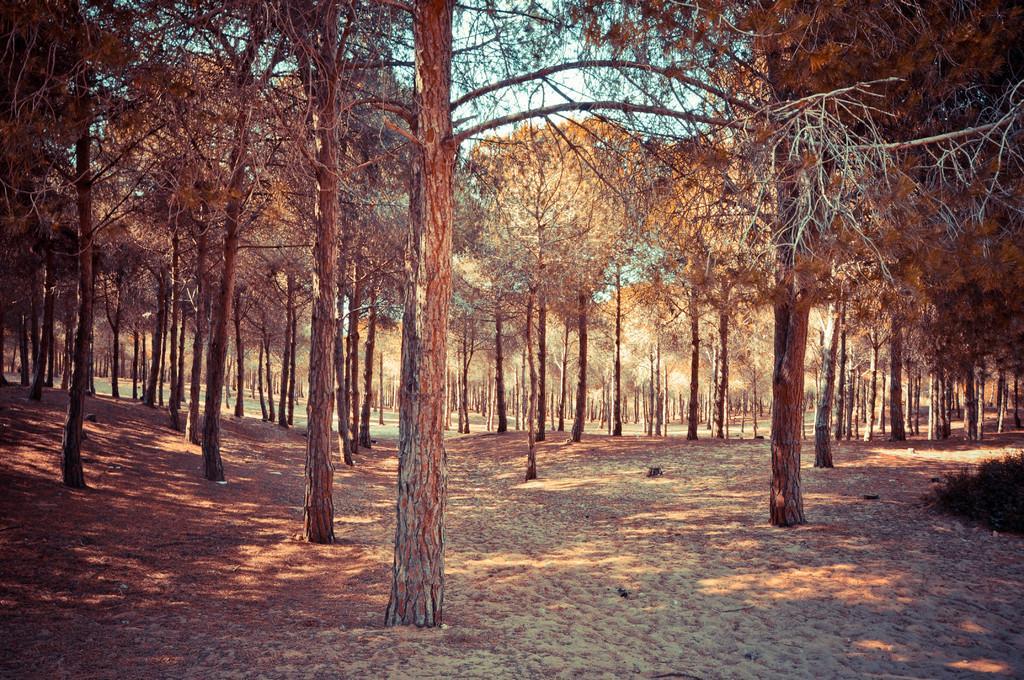Describe this image in one or two sentences. In the center of the image there are trees. At the bottom of the image there is ground. 